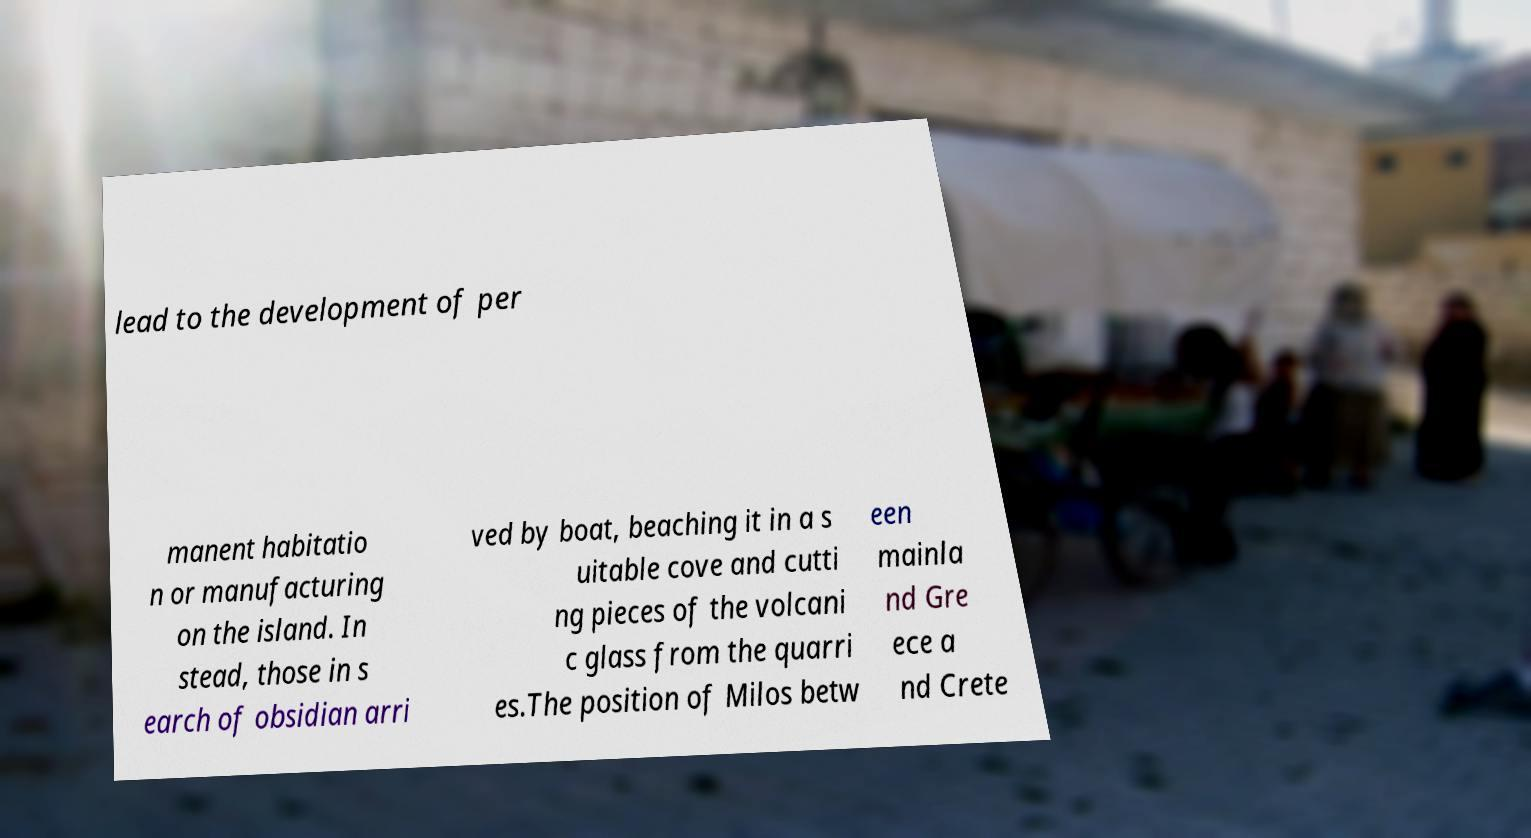I need the written content from this picture converted into text. Can you do that? lead to the development of per manent habitatio n or manufacturing on the island. In stead, those in s earch of obsidian arri ved by boat, beaching it in a s uitable cove and cutti ng pieces of the volcani c glass from the quarri es.The position of Milos betw een mainla nd Gre ece a nd Crete 